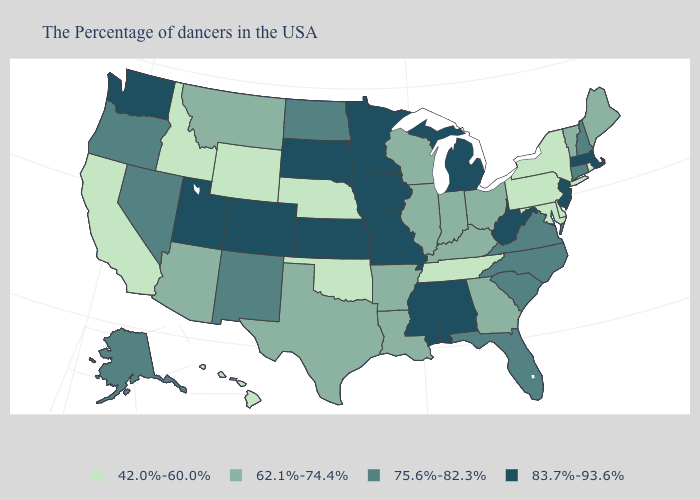What is the value of North Carolina?
Give a very brief answer. 75.6%-82.3%. Which states hav the highest value in the West?
Short answer required. Colorado, Utah, Washington. Does Tennessee have the lowest value in the USA?
Quick response, please. Yes. What is the value of New York?
Give a very brief answer. 42.0%-60.0%. Which states have the lowest value in the USA?
Concise answer only. Rhode Island, New York, Delaware, Maryland, Pennsylvania, Tennessee, Nebraska, Oklahoma, Wyoming, Idaho, California, Hawaii. Name the states that have a value in the range 42.0%-60.0%?
Keep it brief. Rhode Island, New York, Delaware, Maryland, Pennsylvania, Tennessee, Nebraska, Oklahoma, Wyoming, Idaho, California, Hawaii. Does Vermont have a higher value than Virginia?
Quick response, please. No. Does Vermont have the same value as Arizona?
Short answer required. Yes. Name the states that have a value in the range 83.7%-93.6%?
Concise answer only. Massachusetts, New Jersey, West Virginia, Michigan, Alabama, Mississippi, Missouri, Minnesota, Iowa, Kansas, South Dakota, Colorado, Utah, Washington. Is the legend a continuous bar?
Answer briefly. No. Name the states that have a value in the range 62.1%-74.4%?
Write a very short answer. Maine, Vermont, Ohio, Georgia, Kentucky, Indiana, Wisconsin, Illinois, Louisiana, Arkansas, Texas, Montana, Arizona. What is the highest value in the USA?
Answer briefly. 83.7%-93.6%. Does Tennessee have the highest value in the USA?
Write a very short answer. No. Name the states that have a value in the range 62.1%-74.4%?
Quick response, please. Maine, Vermont, Ohio, Georgia, Kentucky, Indiana, Wisconsin, Illinois, Louisiana, Arkansas, Texas, Montana, Arizona. What is the value of Maryland?
Concise answer only. 42.0%-60.0%. 